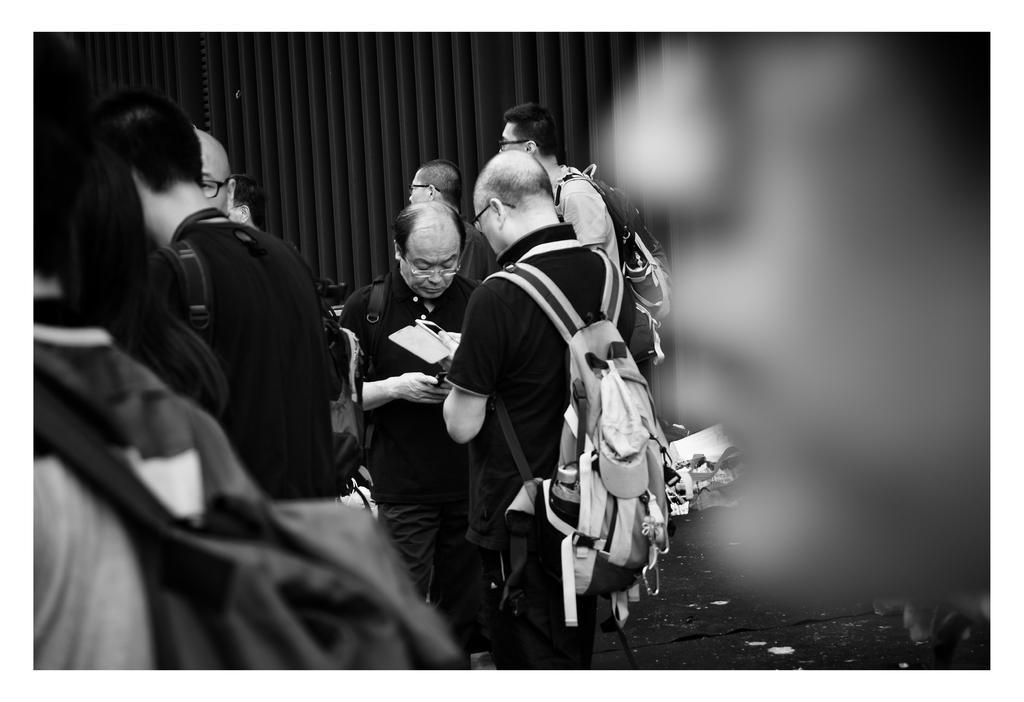Could you give a brief overview of what you see in this image? This image is a black and white image image. This image is taken indoors. In the background there is a window blind. On the right side the image is a little blurred. In the middle of the image four men are standing and two men are holding mobile phones in their hands. On the left side of the image there are a few men. 